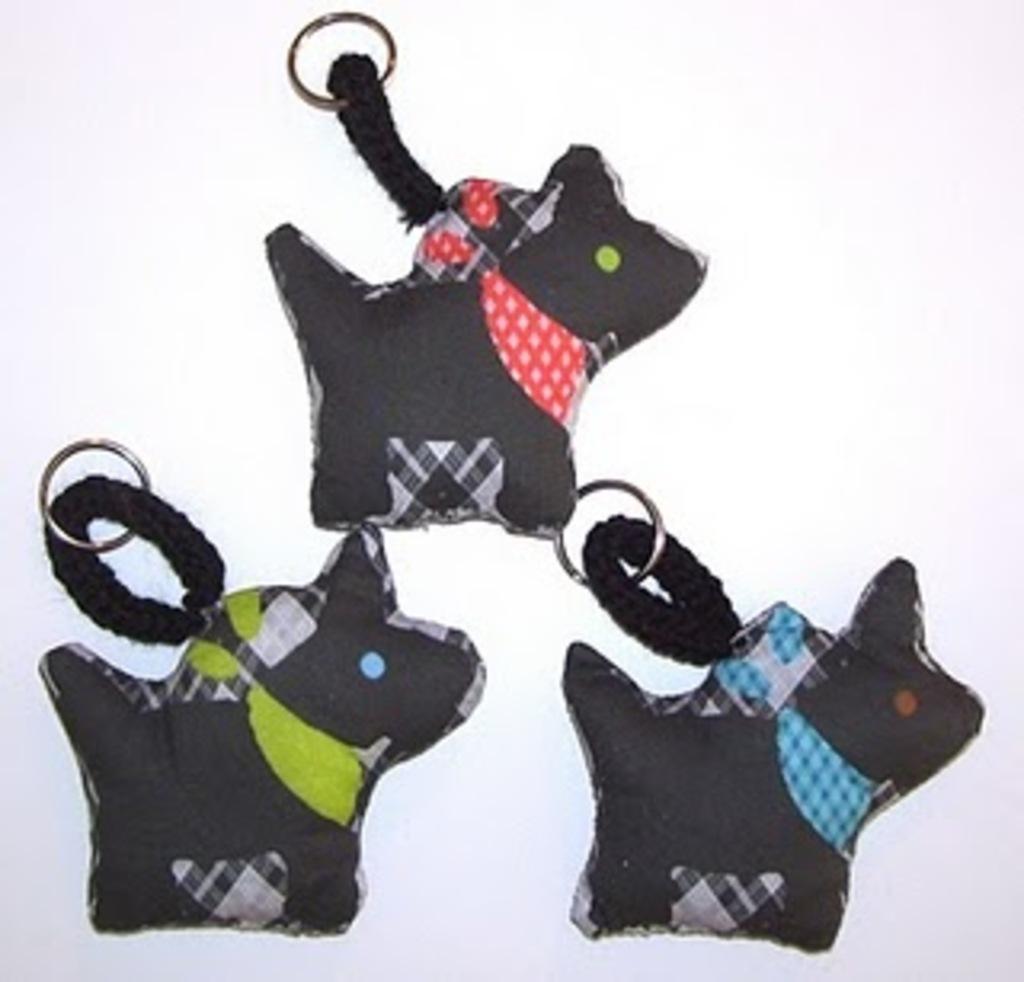How would you summarize this image in a sentence or two? In the image on the white surface to the bottom left of the image there is a key chain of the black color dog with a blue stole. Beside that to the right side of the image there is a another key chain of the dog with blue stole. And to the top of the image there is a keychain of the dog with red stole. 